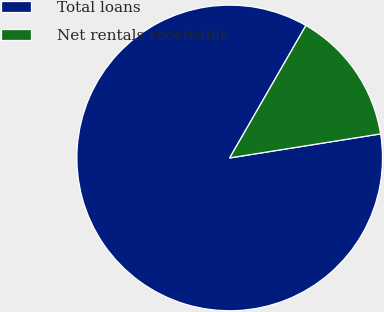<chart> <loc_0><loc_0><loc_500><loc_500><pie_chart><fcel>Total loans<fcel>Net rentals receivable<nl><fcel>85.83%<fcel>14.17%<nl></chart> 